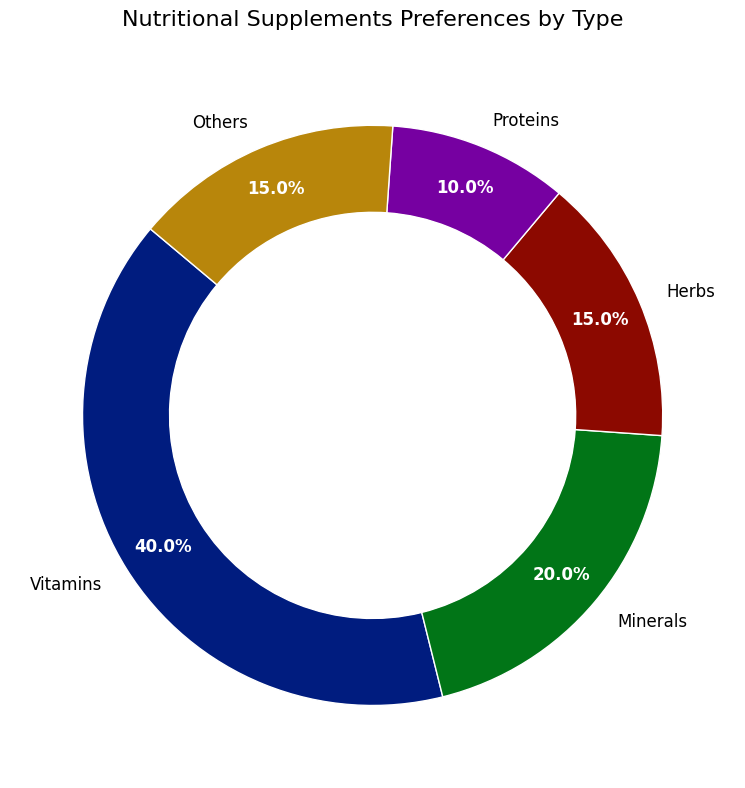What's the most preferred type of nutritional supplement? The figure shows a ring chart with various types of nutritional supplements and their corresponding percentages. The type with the largest segment on the chart is "Vitamins" at 40%.
Answer: Vitamins Which two types of supplements have the same percentage preference? By looking at the figure, you can see that "Herbs" and "Others" both have a 15% preference, indicating they share the same segment size.
Answer: Herbs and Others How much more popular are Vitamins compared to Proteins? The percentage for Vitamins is 40%, and for Proteins, it is 10%. The difference is calculated by subtracting the Proteins percentage from the Vitamins percentage: 40% - 10% = 30%.
Answer: 30% What is the combined percentage of Herbs and Minerals? Herbs have a 15% preference and Minerals have a 20% preference. Adding these together gives 15% + 20% = 35%.
Answer: 35% Which type of supplement is least preferred? From the ring chart, the segment for Proteins is the smallest at 10%, making it the least preferred type of supplement.
Answer: Proteins Are Minerals more preferred than Herbs and Others combined? The percentage for Minerals is 20%. Adding the percentages of Herbs (15%) and Others (15%) gives 15% + 15% = 30%. Since 30% is greater than 20%, Minerals are less preferred.
Answer: No What percentage of the supplements fall under the "Others" category? Referring to the figure, the "Others" category is marked with 15%.
Answer: 15% How much larger is the segment of Vitamins compared to the total percentage of Proteins and Others combined? The percentage for Vitamins is 40%. The combined percentage of Proteins (10%) and Others (15%) is 10% + 15% = 25%. The difference is 40% - 25% = 15%.
Answer: 15% What is the total percentage of all groups except Vitamins? Adding the percentages of Minerals (20%), Herbs (15%), Proteins (10%), and Others (15%) results in 20% + 15% + 10% + 15% = 60%.
Answer: 60% Is any type of supplement preferred by exactly a quarter of the respondents? A quarter of 100% is 25%. The figure does not show any segment with a 25% preference, indicating no type is preferred by exactly a quarter.
Answer: No 